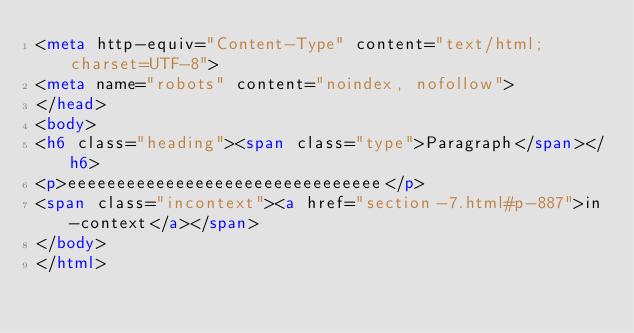<code> <loc_0><loc_0><loc_500><loc_500><_HTML_><meta http-equiv="Content-Type" content="text/html; charset=UTF-8">
<meta name="robots" content="noindex, nofollow">
</head>
<body>
<h6 class="heading"><span class="type">Paragraph</span></h6>
<p>eeeeeeeeeeeeeeeeeeeeeeeeeeeeeeee</p>
<span class="incontext"><a href="section-7.html#p-887">in-context</a></span>
</body>
</html>
</code> 